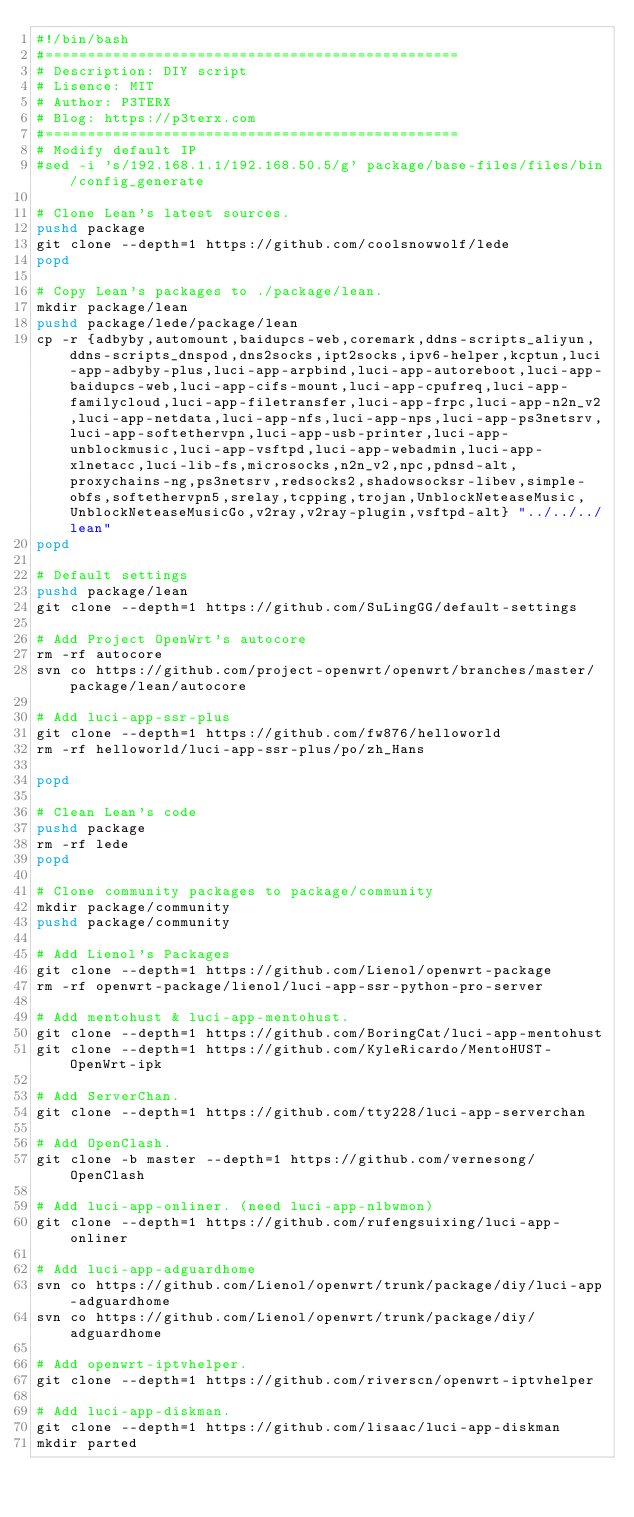Convert code to text. <code><loc_0><loc_0><loc_500><loc_500><_Bash_>#!/bin/bash
#=================================================
# Description: DIY script
# Lisence: MIT
# Author: P3TERX
# Blog: https://p3terx.com
#=================================================
# Modify default IP
#sed -i 's/192.168.1.1/192.168.50.5/g' package/base-files/files/bin/config_generate

# Clone Lean's latest sources.
pushd package
git clone --depth=1 https://github.com/coolsnowwolf/lede
popd

# Copy Lean's packages to ./package/lean.
mkdir package/lean
pushd package/lede/package/lean
cp -r {adbyby,automount,baidupcs-web,coremark,ddns-scripts_aliyun,ddns-scripts_dnspod,dns2socks,ipt2socks,ipv6-helper,kcptun,luci-app-adbyby-plus,luci-app-arpbind,luci-app-autoreboot,luci-app-baidupcs-web,luci-app-cifs-mount,luci-app-cpufreq,luci-app-familycloud,luci-app-filetransfer,luci-app-frpc,luci-app-n2n_v2,luci-app-netdata,luci-app-nfs,luci-app-nps,luci-app-ps3netsrv,luci-app-softethervpn,luci-app-usb-printer,luci-app-unblockmusic,luci-app-vsftpd,luci-app-webadmin,luci-app-xlnetacc,luci-lib-fs,microsocks,n2n_v2,npc,pdnsd-alt,proxychains-ng,ps3netsrv,redsocks2,shadowsocksr-libev,simple-obfs,softethervpn5,srelay,tcpping,trojan,UnblockNeteaseMusic,UnblockNeteaseMusicGo,v2ray,v2ray-plugin,vsftpd-alt} "../../../lean"
popd

# Default settings
pushd package/lean
git clone --depth=1 https://github.com/SuLingGG/default-settings

# Add Project OpenWrt's autocore
rm -rf autocore
svn co https://github.com/project-openwrt/openwrt/branches/master/package/lean/autocore

# Add luci-app-ssr-plus
git clone --depth=1 https://github.com/fw876/helloworld
rm -rf helloworld/luci-app-ssr-plus/po/zh_Hans

popd

# Clean Lean's code
pushd package
rm -rf lede
popd

# Clone community packages to package/community
mkdir package/community
pushd package/community

# Add Lienol's Packages
git clone --depth=1 https://github.com/Lienol/openwrt-package
rm -rf openwrt-package/lienol/luci-app-ssr-python-pro-server

# Add mentohust & luci-app-mentohust.
git clone --depth=1 https://github.com/BoringCat/luci-app-mentohust
git clone --depth=1 https://github.com/KyleRicardo/MentoHUST-OpenWrt-ipk

# Add ServerChan.
git clone --depth=1 https://github.com/tty228/luci-app-serverchan

# Add OpenClash.
git clone -b master --depth=1 https://github.com/vernesong/OpenClash

# Add luci-app-onliner. (need luci-app-nlbwmon)
git clone --depth=1 https://github.com/rufengsuixing/luci-app-onliner

# Add luci-app-adguardhome
svn co https://github.com/Lienol/openwrt/trunk/package/diy/luci-app-adguardhome
svn co https://github.com/Lienol/openwrt/trunk/package/diy/adguardhome

# Add openwrt-iptvhelper.
git clone --depth=1 https://github.com/riverscn/openwrt-iptvhelper

# Add luci-app-diskman.
git clone --depth=1 https://github.com/lisaac/luci-app-diskman
mkdir parted</code> 